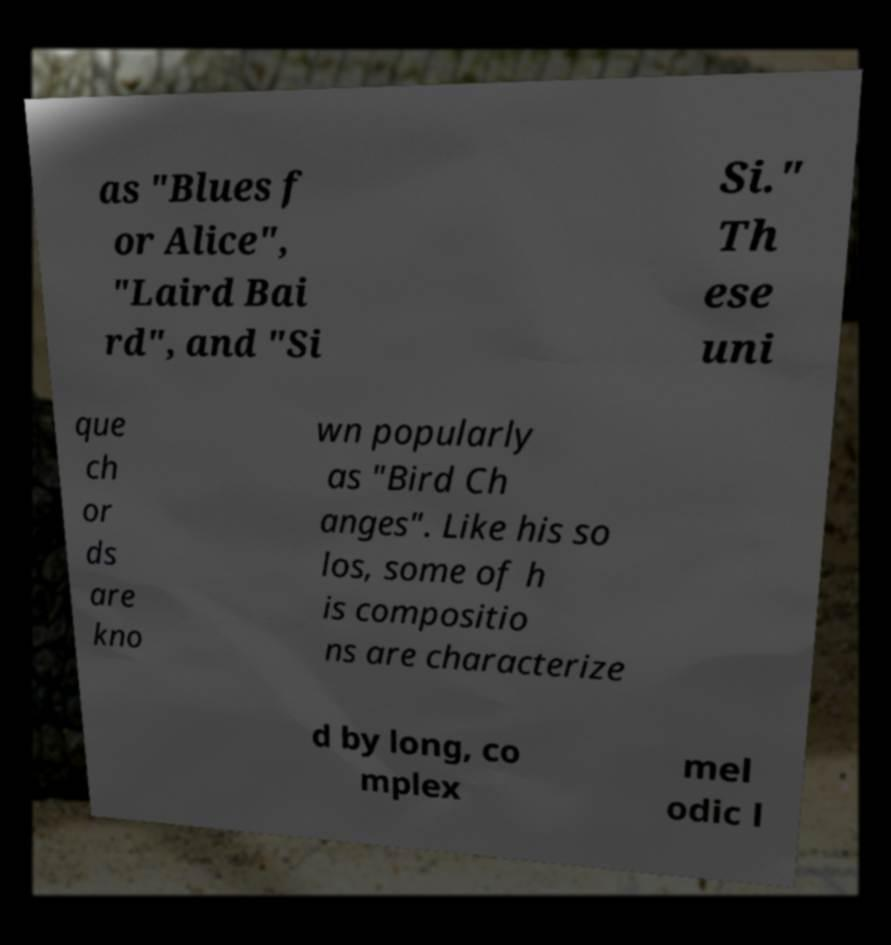For documentation purposes, I need the text within this image transcribed. Could you provide that? as "Blues f or Alice", "Laird Bai rd", and "Si Si." Th ese uni que ch or ds are kno wn popularly as "Bird Ch anges". Like his so los, some of h is compositio ns are characterize d by long, co mplex mel odic l 